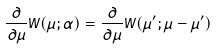Convert formula to latex. <formula><loc_0><loc_0><loc_500><loc_500>\frac { \partial } { \partial \mu } W ( \mu ; \alpha ) = \frac { \partial } { \partial \mu } W ( \mu ^ { \prime } ; \mu - \mu ^ { \prime } )</formula> 